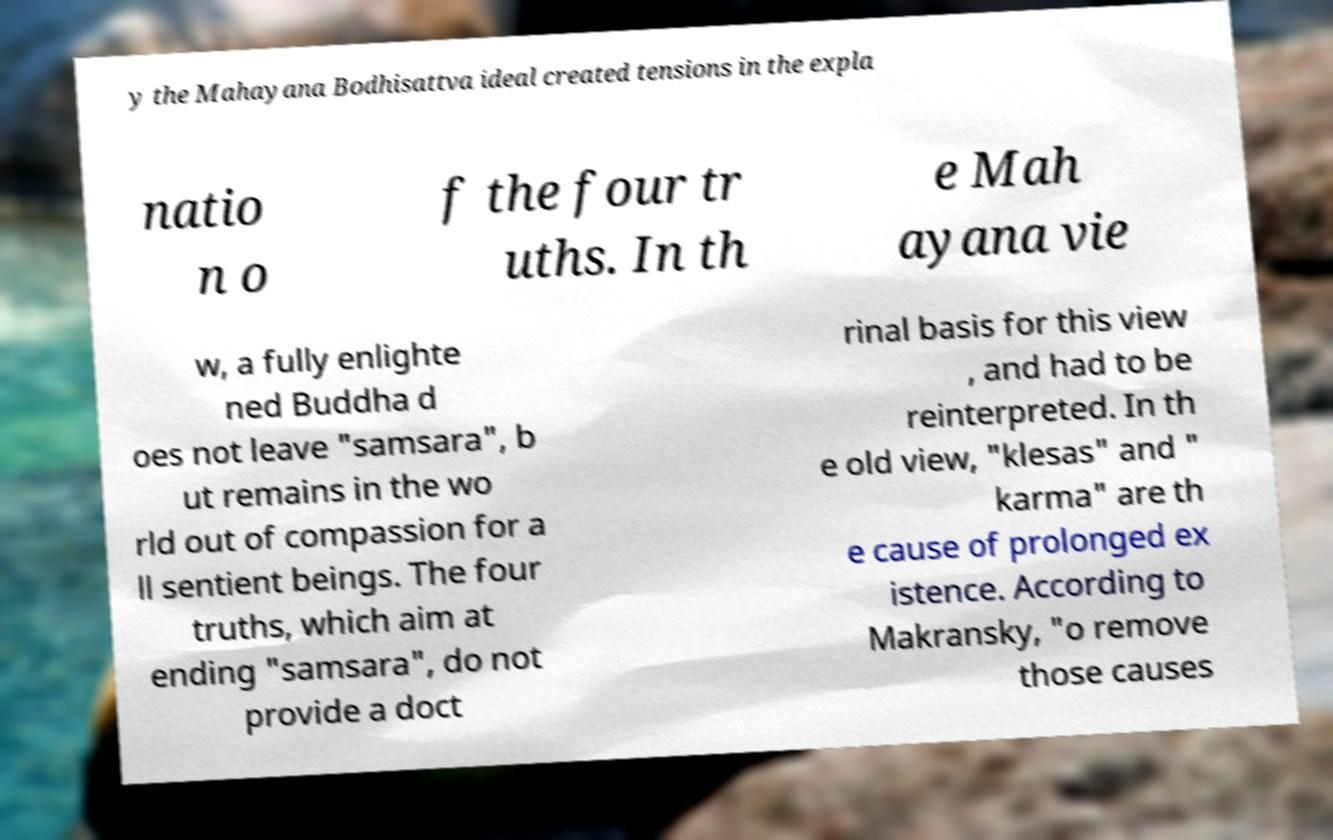Could you extract and type out the text from this image? y the Mahayana Bodhisattva ideal created tensions in the expla natio n o f the four tr uths. In th e Mah ayana vie w, a fully enlighte ned Buddha d oes not leave "samsara", b ut remains in the wo rld out of compassion for a ll sentient beings. The four truths, which aim at ending "samsara", do not provide a doct rinal basis for this view , and had to be reinterpreted. In th e old view, "klesas" and " karma" are th e cause of prolonged ex istence. According to Makransky, "o remove those causes 